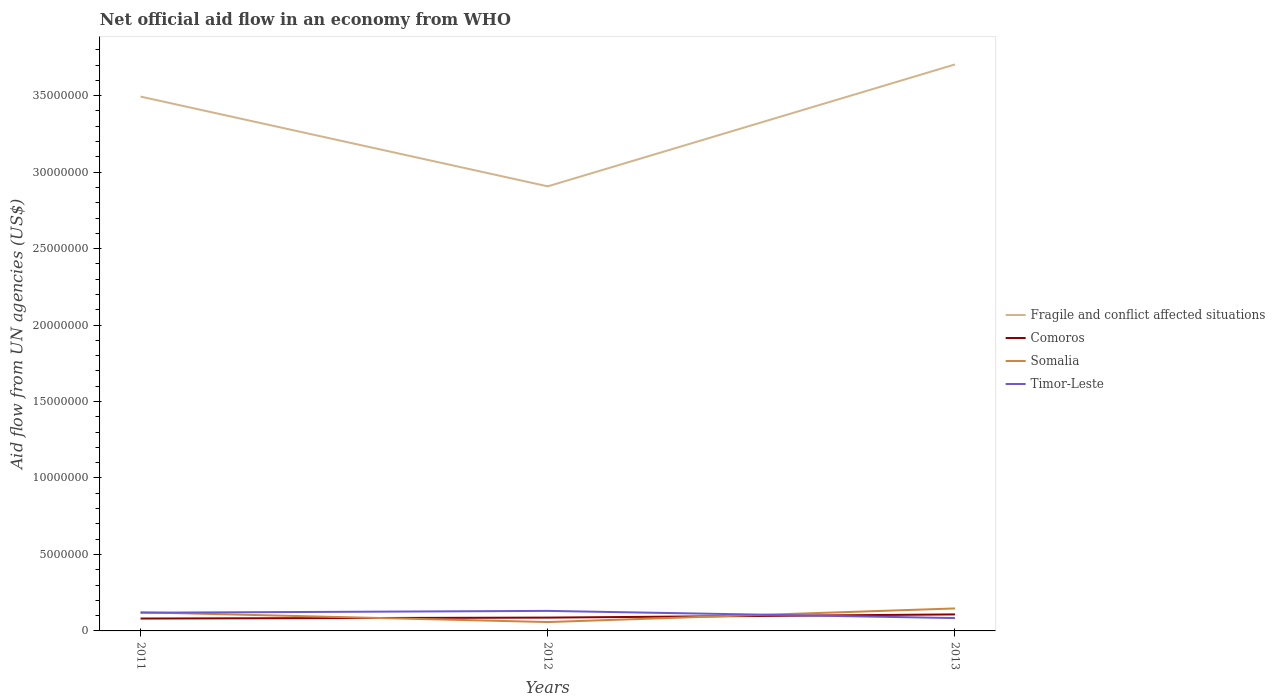How many different coloured lines are there?
Your response must be concise. 4. Does the line corresponding to Somalia intersect with the line corresponding to Timor-Leste?
Your answer should be very brief. Yes. Is the number of lines equal to the number of legend labels?
Your answer should be very brief. Yes. Across all years, what is the maximum net official aid flow in Timor-Leste?
Ensure brevity in your answer.  8.40e+05. In which year was the net official aid flow in Comoros maximum?
Provide a succinct answer. 2011. What is the total net official aid flow in Comoros in the graph?
Your response must be concise. -6.00e+04. What is the difference between the highest and the second highest net official aid flow in Comoros?
Provide a succinct answer. 2.70e+05. Is the net official aid flow in Comoros strictly greater than the net official aid flow in Somalia over the years?
Offer a terse response. No. Are the values on the major ticks of Y-axis written in scientific E-notation?
Provide a succinct answer. No. Does the graph contain any zero values?
Give a very brief answer. No. How many legend labels are there?
Offer a very short reply. 4. What is the title of the graph?
Your answer should be compact. Net official aid flow in an economy from WHO. What is the label or title of the X-axis?
Ensure brevity in your answer.  Years. What is the label or title of the Y-axis?
Give a very brief answer. Aid flow from UN agencies (US$). What is the Aid flow from UN agencies (US$) in Fragile and conflict affected situations in 2011?
Your response must be concise. 3.49e+07. What is the Aid flow from UN agencies (US$) in Comoros in 2011?
Keep it short and to the point. 8.10e+05. What is the Aid flow from UN agencies (US$) in Somalia in 2011?
Provide a short and direct response. 1.22e+06. What is the Aid flow from UN agencies (US$) of Timor-Leste in 2011?
Give a very brief answer. 1.19e+06. What is the Aid flow from UN agencies (US$) in Fragile and conflict affected situations in 2012?
Keep it short and to the point. 2.91e+07. What is the Aid flow from UN agencies (US$) in Comoros in 2012?
Ensure brevity in your answer.  8.70e+05. What is the Aid flow from UN agencies (US$) of Somalia in 2012?
Offer a terse response. 5.80e+05. What is the Aid flow from UN agencies (US$) of Timor-Leste in 2012?
Give a very brief answer. 1.31e+06. What is the Aid flow from UN agencies (US$) in Fragile and conflict affected situations in 2013?
Provide a succinct answer. 3.70e+07. What is the Aid flow from UN agencies (US$) of Comoros in 2013?
Your answer should be compact. 1.08e+06. What is the Aid flow from UN agencies (US$) of Somalia in 2013?
Provide a short and direct response. 1.47e+06. What is the Aid flow from UN agencies (US$) of Timor-Leste in 2013?
Keep it short and to the point. 8.40e+05. Across all years, what is the maximum Aid flow from UN agencies (US$) of Fragile and conflict affected situations?
Provide a short and direct response. 3.70e+07. Across all years, what is the maximum Aid flow from UN agencies (US$) in Comoros?
Keep it short and to the point. 1.08e+06. Across all years, what is the maximum Aid flow from UN agencies (US$) of Somalia?
Keep it short and to the point. 1.47e+06. Across all years, what is the maximum Aid flow from UN agencies (US$) of Timor-Leste?
Your response must be concise. 1.31e+06. Across all years, what is the minimum Aid flow from UN agencies (US$) of Fragile and conflict affected situations?
Your answer should be compact. 2.91e+07. Across all years, what is the minimum Aid flow from UN agencies (US$) in Comoros?
Offer a very short reply. 8.10e+05. Across all years, what is the minimum Aid flow from UN agencies (US$) in Somalia?
Ensure brevity in your answer.  5.80e+05. Across all years, what is the minimum Aid flow from UN agencies (US$) of Timor-Leste?
Offer a terse response. 8.40e+05. What is the total Aid flow from UN agencies (US$) in Fragile and conflict affected situations in the graph?
Provide a short and direct response. 1.01e+08. What is the total Aid flow from UN agencies (US$) of Comoros in the graph?
Provide a succinct answer. 2.76e+06. What is the total Aid flow from UN agencies (US$) of Somalia in the graph?
Your response must be concise. 3.27e+06. What is the total Aid flow from UN agencies (US$) in Timor-Leste in the graph?
Ensure brevity in your answer.  3.34e+06. What is the difference between the Aid flow from UN agencies (US$) of Fragile and conflict affected situations in 2011 and that in 2012?
Your answer should be very brief. 5.87e+06. What is the difference between the Aid flow from UN agencies (US$) of Comoros in 2011 and that in 2012?
Your response must be concise. -6.00e+04. What is the difference between the Aid flow from UN agencies (US$) in Somalia in 2011 and that in 2012?
Provide a succinct answer. 6.40e+05. What is the difference between the Aid flow from UN agencies (US$) in Timor-Leste in 2011 and that in 2012?
Your answer should be compact. -1.20e+05. What is the difference between the Aid flow from UN agencies (US$) in Fragile and conflict affected situations in 2011 and that in 2013?
Make the answer very short. -2.10e+06. What is the difference between the Aid flow from UN agencies (US$) in Comoros in 2011 and that in 2013?
Provide a short and direct response. -2.70e+05. What is the difference between the Aid flow from UN agencies (US$) of Timor-Leste in 2011 and that in 2013?
Make the answer very short. 3.50e+05. What is the difference between the Aid flow from UN agencies (US$) in Fragile and conflict affected situations in 2012 and that in 2013?
Offer a very short reply. -7.97e+06. What is the difference between the Aid flow from UN agencies (US$) in Comoros in 2012 and that in 2013?
Ensure brevity in your answer.  -2.10e+05. What is the difference between the Aid flow from UN agencies (US$) in Somalia in 2012 and that in 2013?
Your answer should be very brief. -8.90e+05. What is the difference between the Aid flow from UN agencies (US$) of Fragile and conflict affected situations in 2011 and the Aid flow from UN agencies (US$) of Comoros in 2012?
Offer a terse response. 3.41e+07. What is the difference between the Aid flow from UN agencies (US$) in Fragile and conflict affected situations in 2011 and the Aid flow from UN agencies (US$) in Somalia in 2012?
Offer a terse response. 3.44e+07. What is the difference between the Aid flow from UN agencies (US$) in Fragile and conflict affected situations in 2011 and the Aid flow from UN agencies (US$) in Timor-Leste in 2012?
Give a very brief answer. 3.36e+07. What is the difference between the Aid flow from UN agencies (US$) of Comoros in 2011 and the Aid flow from UN agencies (US$) of Timor-Leste in 2012?
Your answer should be compact. -5.00e+05. What is the difference between the Aid flow from UN agencies (US$) of Somalia in 2011 and the Aid flow from UN agencies (US$) of Timor-Leste in 2012?
Give a very brief answer. -9.00e+04. What is the difference between the Aid flow from UN agencies (US$) in Fragile and conflict affected situations in 2011 and the Aid flow from UN agencies (US$) in Comoros in 2013?
Provide a short and direct response. 3.39e+07. What is the difference between the Aid flow from UN agencies (US$) of Fragile and conflict affected situations in 2011 and the Aid flow from UN agencies (US$) of Somalia in 2013?
Your response must be concise. 3.35e+07. What is the difference between the Aid flow from UN agencies (US$) in Fragile and conflict affected situations in 2011 and the Aid flow from UN agencies (US$) in Timor-Leste in 2013?
Give a very brief answer. 3.41e+07. What is the difference between the Aid flow from UN agencies (US$) of Comoros in 2011 and the Aid flow from UN agencies (US$) of Somalia in 2013?
Your answer should be very brief. -6.60e+05. What is the difference between the Aid flow from UN agencies (US$) of Somalia in 2011 and the Aid flow from UN agencies (US$) of Timor-Leste in 2013?
Provide a succinct answer. 3.80e+05. What is the difference between the Aid flow from UN agencies (US$) in Fragile and conflict affected situations in 2012 and the Aid flow from UN agencies (US$) in Comoros in 2013?
Your answer should be very brief. 2.80e+07. What is the difference between the Aid flow from UN agencies (US$) of Fragile and conflict affected situations in 2012 and the Aid flow from UN agencies (US$) of Somalia in 2013?
Give a very brief answer. 2.76e+07. What is the difference between the Aid flow from UN agencies (US$) in Fragile and conflict affected situations in 2012 and the Aid flow from UN agencies (US$) in Timor-Leste in 2013?
Make the answer very short. 2.82e+07. What is the difference between the Aid flow from UN agencies (US$) of Comoros in 2012 and the Aid flow from UN agencies (US$) of Somalia in 2013?
Offer a very short reply. -6.00e+05. What is the difference between the Aid flow from UN agencies (US$) in Comoros in 2012 and the Aid flow from UN agencies (US$) in Timor-Leste in 2013?
Give a very brief answer. 3.00e+04. What is the difference between the Aid flow from UN agencies (US$) in Somalia in 2012 and the Aid flow from UN agencies (US$) in Timor-Leste in 2013?
Your answer should be very brief. -2.60e+05. What is the average Aid flow from UN agencies (US$) in Fragile and conflict affected situations per year?
Your response must be concise. 3.37e+07. What is the average Aid flow from UN agencies (US$) of Comoros per year?
Ensure brevity in your answer.  9.20e+05. What is the average Aid flow from UN agencies (US$) in Somalia per year?
Offer a very short reply. 1.09e+06. What is the average Aid flow from UN agencies (US$) in Timor-Leste per year?
Ensure brevity in your answer.  1.11e+06. In the year 2011, what is the difference between the Aid flow from UN agencies (US$) of Fragile and conflict affected situations and Aid flow from UN agencies (US$) of Comoros?
Your response must be concise. 3.41e+07. In the year 2011, what is the difference between the Aid flow from UN agencies (US$) in Fragile and conflict affected situations and Aid flow from UN agencies (US$) in Somalia?
Provide a short and direct response. 3.37e+07. In the year 2011, what is the difference between the Aid flow from UN agencies (US$) of Fragile and conflict affected situations and Aid flow from UN agencies (US$) of Timor-Leste?
Offer a terse response. 3.38e+07. In the year 2011, what is the difference between the Aid flow from UN agencies (US$) of Comoros and Aid flow from UN agencies (US$) of Somalia?
Your answer should be very brief. -4.10e+05. In the year 2011, what is the difference between the Aid flow from UN agencies (US$) of Comoros and Aid flow from UN agencies (US$) of Timor-Leste?
Ensure brevity in your answer.  -3.80e+05. In the year 2012, what is the difference between the Aid flow from UN agencies (US$) of Fragile and conflict affected situations and Aid flow from UN agencies (US$) of Comoros?
Your answer should be compact. 2.82e+07. In the year 2012, what is the difference between the Aid flow from UN agencies (US$) in Fragile and conflict affected situations and Aid flow from UN agencies (US$) in Somalia?
Your answer should be compact. 2.85e+07. In the year 2012, what is the difference between the Aid flow from UN agencies (US$) of Fragile and conflict affected situations and Aid flow from UN agencies (US$) of Timor-Leste?
Offer a terse response. 2.78e+07. In the year 2012, what is the difference between the Aid flow from UN agencies (US$) of Comoros and Aid flow from UN agencies (US$) of Somalia?
Ensure brevity in your answer.  2.90e+05. In the year 2012, what is the difference between the Aid flow from UN agencies (US$) of Comoros and Aid flow from UN agencies (US$) of Timor-Leste?
Provide a short and direct response. -4.40e+05. In the year 2012, what is the difference between the Aid flow from UN agencies (US$) in Somalia and Aid flow from UN agencies (US$) in Timor-Leste?
Provide a succinct answer. -7.30e+05. In the year 2013, what is the difference between the Aid flow from UN agencies (US$) in Fragile and conflict affected situations and Aid flow from UN agencies (US$) in Comoros?
Your response must be concise. 3.60e+07. In the year 2013, what is the difference between the Aid flow from UN agencies (US$) in Fragile and conflict affected situations and Aid flow from UN agencies (US$) in Somalia?
Your response must be concise. 3.56e+07. In the year 2013, what is the difference between the Aid flow from UN agencies (US$) in Fragile and conflict affected situations and Aid flow from UN agencies (US$) in Timor-Leste?
Offer a terse response. 3.62e+07. In the year 2013, what is the difference between the Aid flow from UN agencies (US$) in Comoros and Aid flow from UN agencies (US$) in Somalia?
Your answer should be very brief. -3.90e+05. In the year 2013, what is the difference between the Aid flow from UN agencies (US$) of Somalia and Aid flow from UN agencies (US$) of Timor-Leste?
Your response must be concise. 6.30e+05. What is the ratio of the Aid flow from UN agencies (US$) in Fragile and conflict affected situations in 2011 to that in 2012?
Provide a short and direct response. 1.2. What is the ratio of the Aid flow from UN agencies (US$) in Somalia in 2011 to that in 2012?
Your response must be concise. 2.1. What is the ratio of the Aid flow from UN agencies (US$) of Timor-Leste in 2011 to that in 2012?
Provide a short and direct response. 0.91. What is the ratio of the Aid flow from UN agencies (US$) in Fragile and conflict affected situations in 2011 to that in 2013?
Make the answer very short. 0.94. What is the ratio of the Aid flow from UN agencies (US$) of Comoros in 2011 to that in 2013?
Offer a very short reply. 0.75. What is the ratio of the Aid flow from UN agencies (US$) of Somalia in 2011 to that in 2013?
Offer a terse response. 0.83. What is the ratio of the Aid flow from UN agencies (US$) of Timor-Leste in 2011 to that in 2013?
Ensure brevity in your answer.  1.42. What is the ratio of the Aid flow from UN agencies (US$) in Fragile and conflict affected situations in 2012 to that in 2013?
Your answer should be compact. 0.78. What is the ratio of the Aid flow from UN agencies (US$) of Comoros in 2012 to that in 2013?
Keep it short and to the point. 0.81. What is the ratio of the Aid flow from UN agencies (US$) of Somalia in 2012 to that in 2013?
Your answer should be compact. 0.39. What is the ratio of the Aid flow from UN agencies (US$) of Timor-Leste in 2012 to that in 2013?
Make the answer very short. 1.56. What is the difference between the highest and the second highest Aid flow from UN agencies (US$) in Fragile and conflict affected situations?
Your answer should be compact. 2.10e+06. What is the difference between the highest and the lowest Aid flow from UN agencies (US$) in Fragile and conflict affected situations?
Make the answer very short. 7.97e+06. What is the difference between the highest and the lowest Aid flow from UN agencies (US$) of Somalia?
Provide a short and direct response. 8.90e+05. What is the difference between the highest and the lowest Aid flow from UN agencies (US$) in Timor-Leste?
Give a very brief answer. 4.70e+05. 